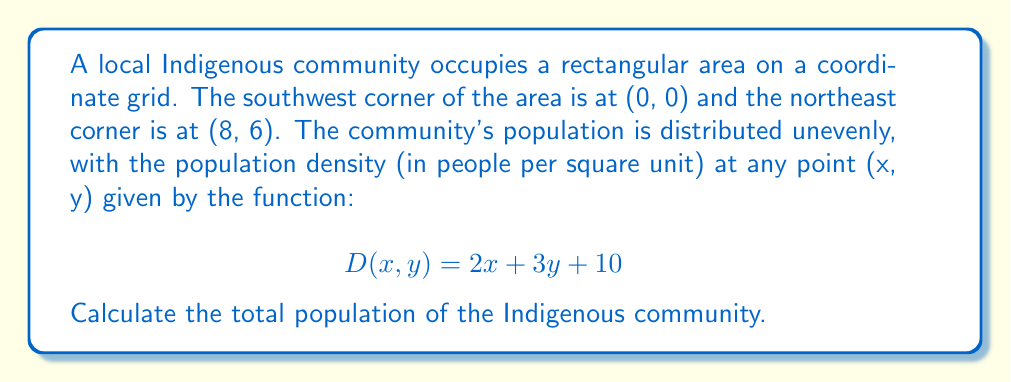Show me your answer to this math problem. To solve this problem, we need to follow these steps:

1) First, we need to understand that the total population is the integral of the density function over the given area. In mathematical terms:

   $$ \text{Total Population} = \iint_A D(x,y) \, dA $$

   where $A$ is the area of the community.

2) The limits of integration are from 0 to 8 for x, and from 0 to 6 for y. So our integral becomes:

   $$ \text{Total Population} = \int_0^6 \int_0^8 (2x + 3y + 10) \, dx \, dy $$

3) Let's solve the inner integral first:

   $$ \int_0^8 (2x + 3y + 10) \, dx = [x^2 + 3xy + 10x]_0^8 = (64 + 24y + 80) - (0) = 144 + 24y $$

4) Now our integral has become:

   $$ \text{Total Population} = \int_0^6 (144 + 24y) \, dy $$

5) Solving this:

   $$ \text{Total Population} = [144y + 12y^2]_0^6 = (864 + 432) - (0) = 1296 $$

Therefore, the total population of the Indigenous community is 1296 people.
Answer: 1296 people 